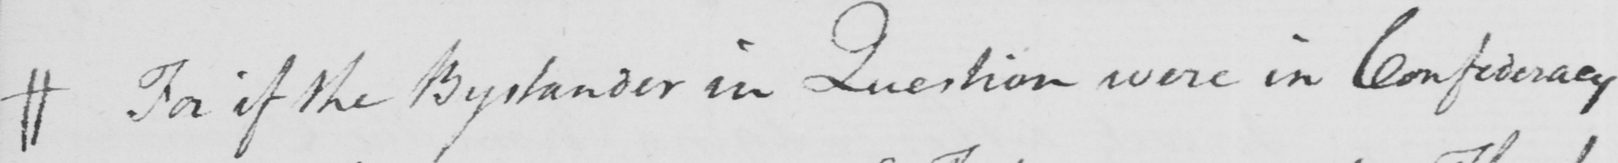What does this handwritten line say? # For if the Bystander in Question were in Confederacy 